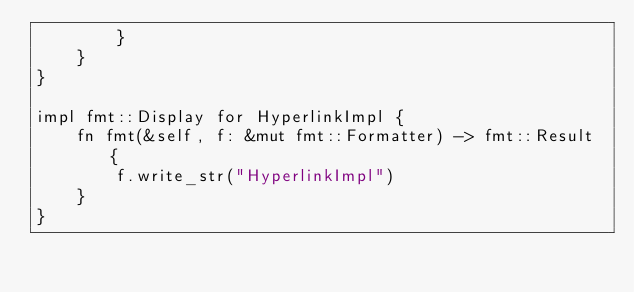Convert code to text. <code><loc_0><loc_0><loc_500><loc_500><_Rust_>        }
    }
}

impl fmt::Display for HyperlinkImpl {
    fn fmt(&self, f: &mut fmt::Formatter) -> fmt::Result {
        f.write_str("HyperlinkImpl")
    }
}
</code> 